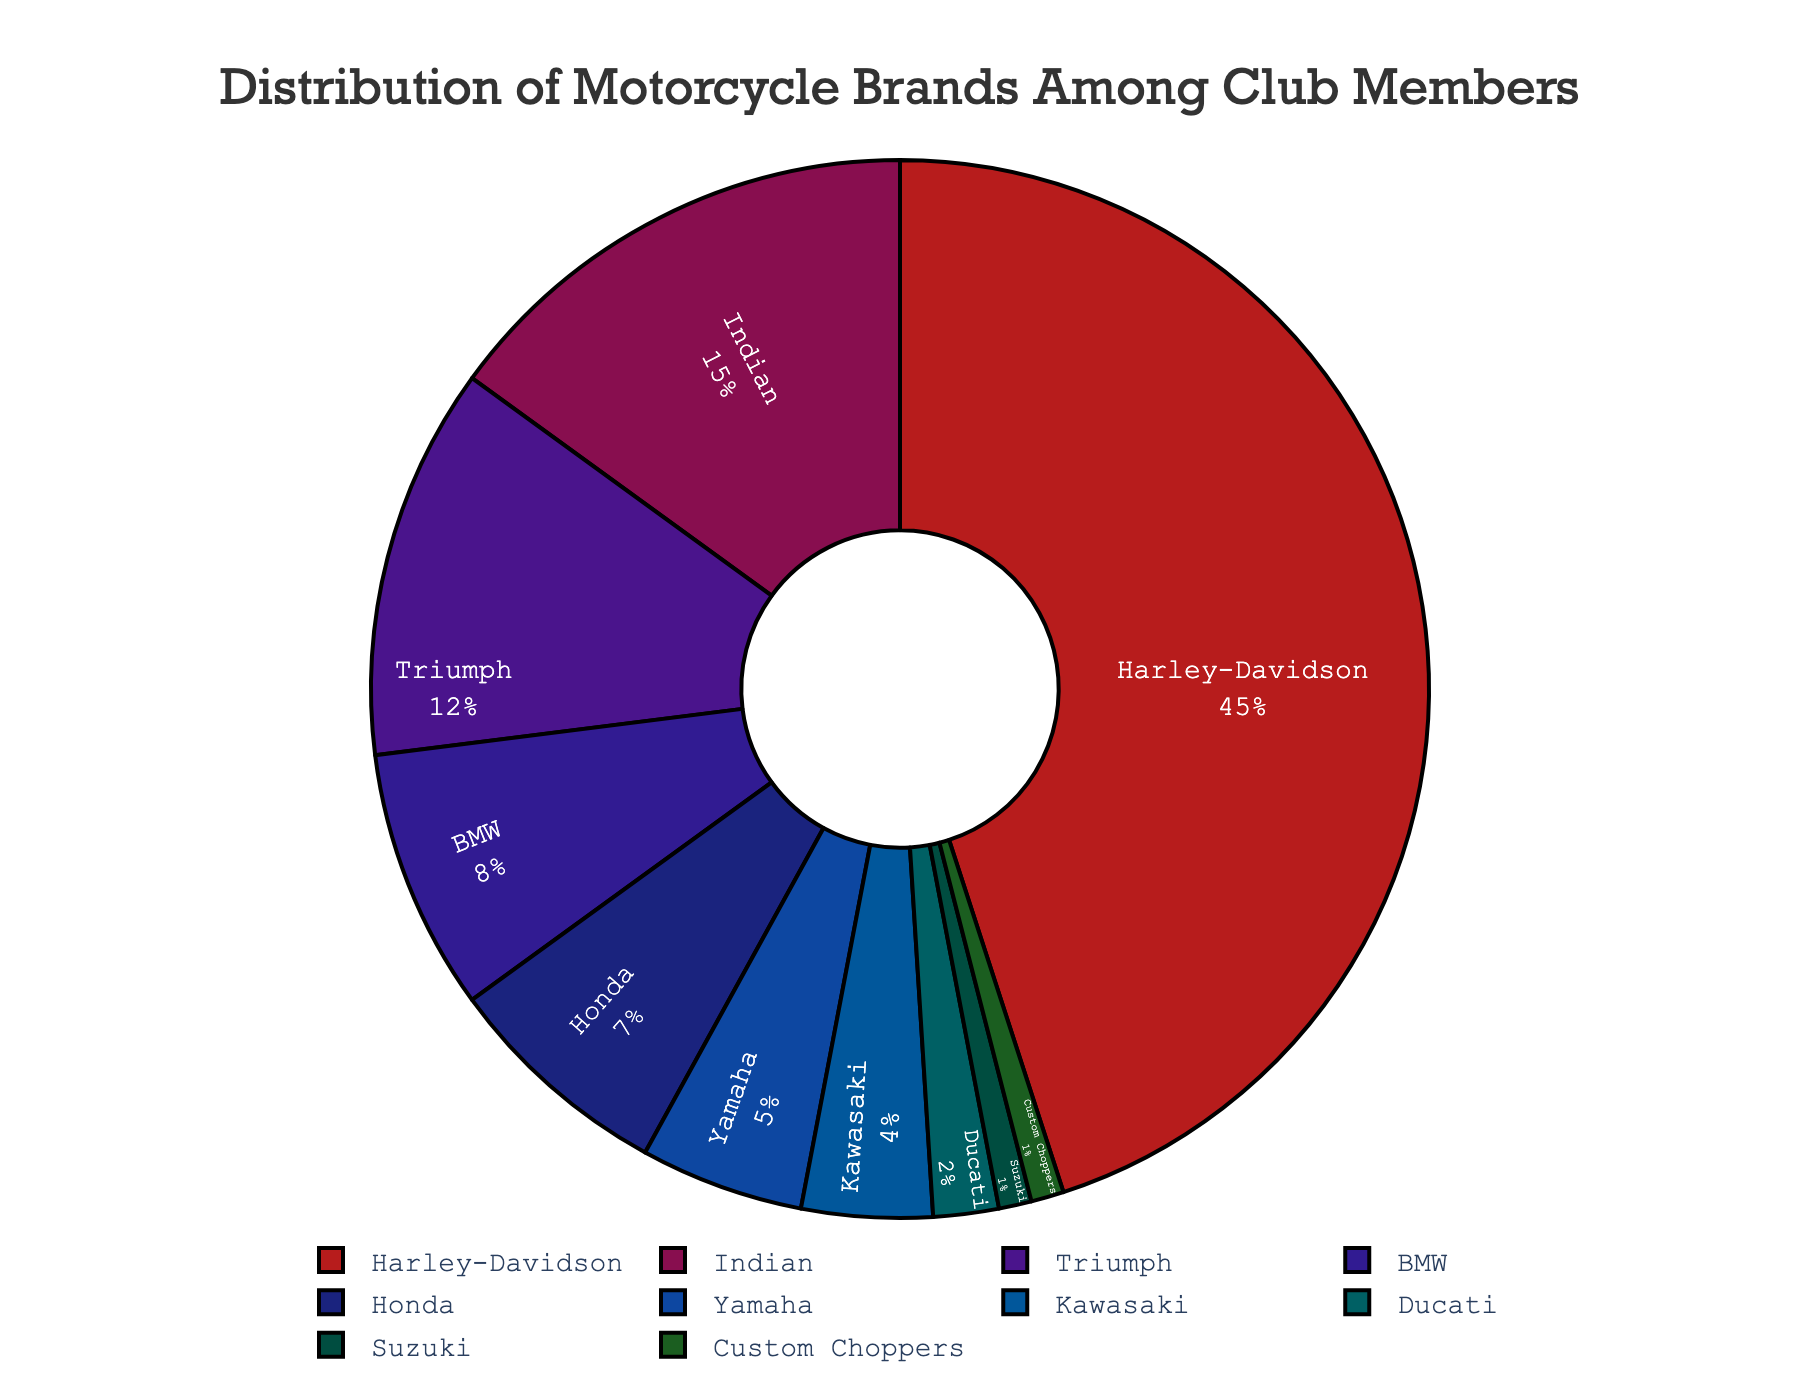Which motorcycle brand is most preferred among club members? Look at the segment with the highest percentage. Harley-Davidson has the largest slice at 45%.
Answer: Harley-Davidson How much more popular is Honda compared to Suzuki? Compare the percentages of Honda and Suzuki by subtracting Suzuki's 1% from Honda's 7%. 7% - 1% = 6%.
Answer: 6% What is the combined percentage of club members that own either a Triumph or a BMW? Add the percentages of Triumph (12%) and BMW (8%). 12% + 8% = 20%.
Answer: 20% Which brand is less popular, Ducati or Custom Choppers? Compare the segments for Ducati (2%) and Custom Choppers (1%). The smaller segment indicates that Custom Choppers is less popular.
Answer: Custom Choppers What percentage of club members own either Yamaha or Kawasaki? Add the percentages of Yamaha (5%) and Kawasaki (4%). 5% + 4% = 9%.
Answer: 9% Which two brands combined make up exactly half of the club members' preferences? Find two brands whose percentages sum to 50%. Harley-Davidson (45%) and Indian (15%) don't sum up to 50%, Honda and Indian don’t either, but Harley-Davidson (45%) and Triumph (12%) do not—there are no two brands summing exactly to 50%. Therefore, no pair sums to exactly 50%.
Answer: None Is the percentage of Ducati users higher than Suzuki users? Compare the percentages of Ducati (2%) and Suzuki (1%). 2% is greater than 1%.
Answer: Yes What's the second most preferred motorcycle brand among club members? Look at the segment with the second highest percentage after Harley-Davidson. Indian has the next highest percentage at 15%.
Answer: Indian By what percentage does the Harley-Davidson segment exceed the total percentage of Honda, Yamaha, Kawasaki, Ducati, Suzuki, and Custom Choppers combined? Sum up the percentages of Honda (7%), Yamaha (5%), Kawasaki (4%), Ducati (2%), Suzuki (1%), and Custom Choppers (1%) first. 7% + 5% + 4% + 2% + 1% + 1% = 20%. Then subtract this from Harley-Davidson's 45%. 45% - 20% = 25%.
Answer: 25% Which motorcycle brands collectively have a smaller percentage than Indian? Look for brands with individual percentages smaller than Indian's 15% and sum them. Triumph (12%), BMW (8%), Honda (7%), Yamaha (5%), Kawasaki (4%), Ducati (2%), Suzuki (1%), Custom Choppers (1%). All these collectively have a smaller percentage.
Answer: Triumph, BMW, Honda, Yamaha, Kawasaki, Ducati, Suzuki, Custom Choppers 